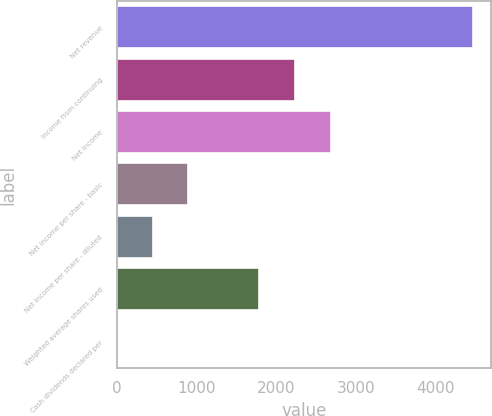Convert chart. <chart><loc_0><loc_0><loc_500><loc_500><bar_chart><fcel>Net revenue<fcel>Income from continuing<fcel>Net income<fcel>Net income per share - basic<fcel>Net income per share - diluted<fcel>Weighted average shares used<fcel>Cash dividends declared per<nl><fcel>4472<fcel>2236.28<fcel>2683.43<fcel>894.83<fcel>447.68<fcel>1789.13<fcel>0.53<nl></chart> 